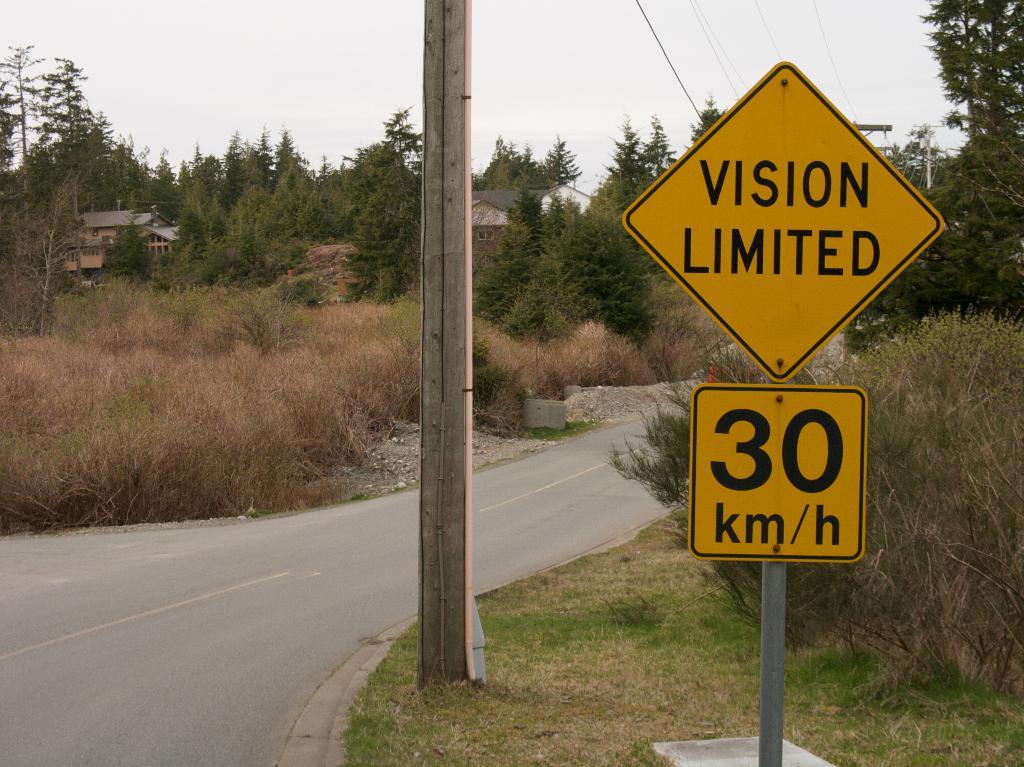What is the speed limit on this road?
Offer a very short reply. 30 km/h. What is limited on the sign?
Your response must be concise. Vision. 